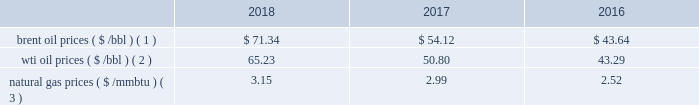Bhge 2018 form 10-k | 31 business environment the following discussion and analysis summarizes the significant factors affecting our results of operations , financial condition and liquidity position as of and for the year ended december 31 , 2018 , 2017 and 2016 , and should be read in conjunction with the consolidated and combined financial statements and related notes of the company .
We operate in more than 120 countries helping customers find , evaluate , drill , produce , transport and process hydrocarbon resources .
Our revenue is predominately generated from the sale of products and services to major , national , and independent oil and natural gas companies worldwide , and is dependent on spending by our customers for oil and natural gas exploration , field development and production .
This spending is driven by a number of factors , including our customers' forecasts of future energy demand and supply , their access to resources to develop and produce oil and natural gas , their ability to fund their capital programs , the impact of new government regulations and most importantly , their expectations for oil and natural gas prices as a key driver of their cash flows .
Oil and natural gas prices oil and natural gas prices are summarized in the table below as averages of the daily closing prices during each of the periods indicated. .
Brent oil prices ( $ /bbl ) ( 1 ) $ 71.34 $ 54.12 $ 43.64 wti oil prices ( $ /bbl ) ( 2 ) 65.23 50.80 43.29 natural gas prices ( $ /mmbtu ) ( 3 ) 3.15 2.99 2.52 ( 1 ) energy information administration ( eia ) europe brent spot price per barrel ( 2 ) eia cushing , ok wti ( west texas intermediate ) spot price ( 3 ) eia henry hub natural gas spot price per million british thermal unit 2018 demonstrated the volatility of the oil and gas market .
Through the first three quarters of 2018 , we experienced stability in the north american and international markets .
However , in the fourth quarter of 2018 commodity prices dropped nearly 40% ( 40 % ) resulting in increased customer uncertainty .
From an offshore standpoint , through most of 2018 , we saw multiple large offshore projects reach positive final investment decisions , and the lng market and outlook improved throughout 2018 , driven by increased demand globally .
In 2018 , the first large north american lng positive final investment decision was reached .
Outside of north america , customer spending is highly driven by brent oil prices , which increased on average throughout the year .
Average brent oil prices increased to $ 71.34/bbl in 2018 from $ 54.12/bbl in 2017 , and ranged from a low of $ 50.57/bbl in december 2018 , to a high of $ 86.07/bbl in october 2018 .
For the first three quarters of 2018 , brent oil prices increased sequentially .
However , in the fourth quarter , brent oil prices declined 39% ( 39 % ) versus the end of the third quarter , as a result of increased supply from the u.s. , worries of a global economic slowdown , and lower than expected production cuts .
In north america , customer spending is highly driven by wti oil prices , which similar to brent oil prices , on average increased throughout the year .
Average wti oil prices increased to $ 65.23/bbl in 2018 from $ 50.80/bbl in 2017 , and ranged from a low of $ 44.48/bbl in december 2018 , to a high of $ 77.41/bbl in june 2018 .
In north america , natural gas prices , as measured by the henry hub natural gas spot price , averaged $ 3.15/ mmbtu in 2018 , representing a 6% ( 6 % ) increase over the prior year .
Throughout the year , henry hub natural gas spot prices ranged from a high of $ 6.24/mmbtu in january 2018 to a low of $ 2.49/mmbtu in february 2018 .
According to the u.s .
Department of energy ( doe ) , working natural gas in storage at the end of 2018 was 2705 billion cubic feet ( bcf ) , which was 15.6% ( 15.6 % ) , or 421 bcf , below the corresponding week in 2017. .
What are the natural gas prices as a percentage of the wti oil prices in 2017? 
Computations: (2.99 / 54.12)
Answer: 0.05525. 